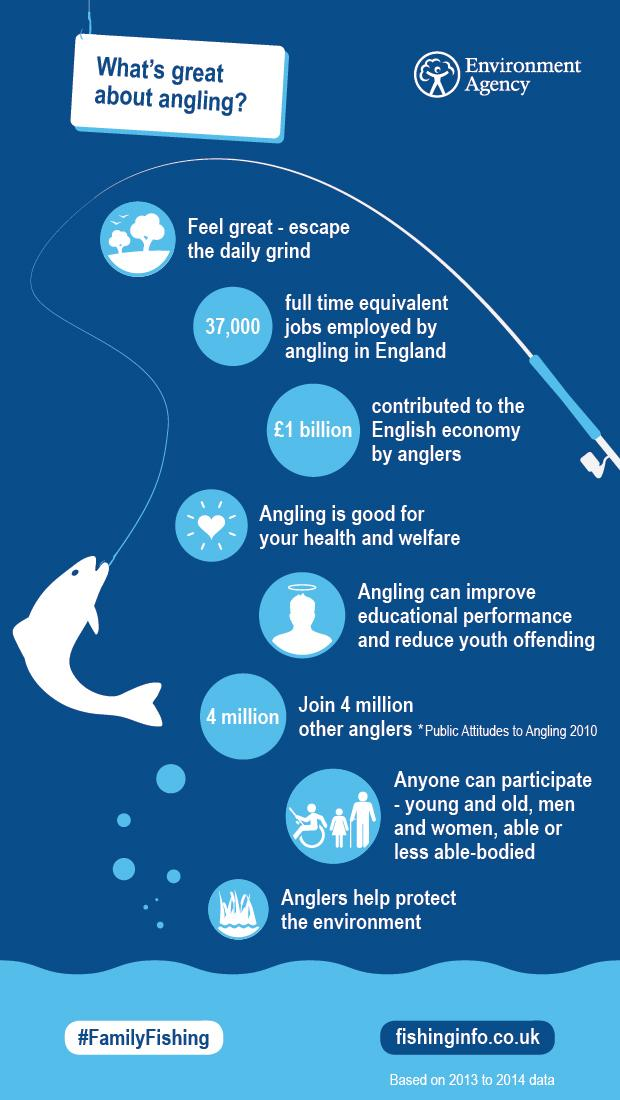List a handful of essential elements in this visual. The color of the fish is blue, white, or green. The speaker stated that the color of the fish is white. The image that indicates angling is good for health is heart. There are approximately 4 million anglers in our country. Fishing with a rod is also commonly referred to as angling. The second circle represents the number of jobs, education, or economic contribution, and the number of jobs is what it stands for. 